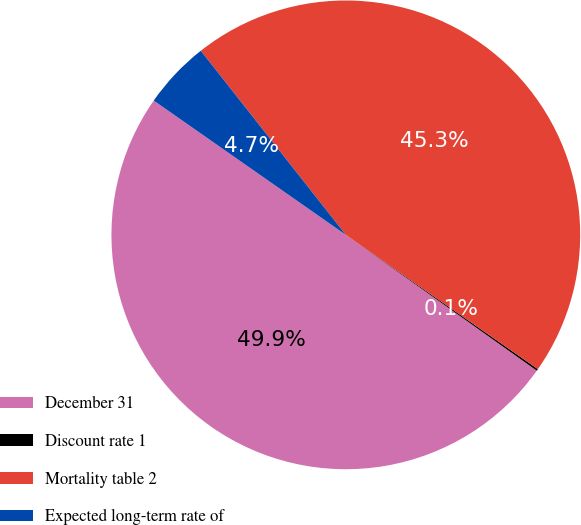Convert chart to OTSL. <chart><loc_0><loc_0><loc_500><loc_500><pie_chart><fcel>December 31<fcel>Discount rate 1<fcel>Mortality table 2<fcel>Expected long-term rate of<nl><fcel>49.87%<fcel>0.13%<fcel>45.33%<fcel>4.67%<nl></chart> 